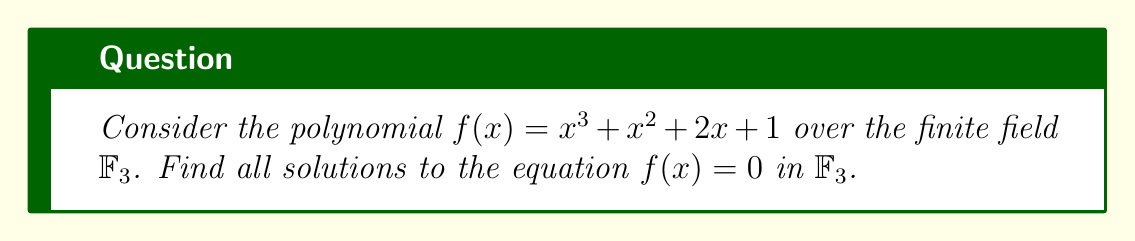Solve this math problem. To solve this polynomial equation over $\mathbb{F}_3$, we'll use factorization techniques:

1) First, recall that in $\mathbb{F}_3$, all elements are congruent to 0, 1, or 2 mod 3.

2) We can try to factor $f(x)$ by testing all possible linear factors $(x - a)$ where $a \in \mathbb{F}_3$:

   For $a = 0$: $f(0) = 0^3 + 0^2 + 2(0) + 1 \equiv 1 \pmod{3}$
   For $a = 1$: $f(1) = 1^3 + 1^2 + 2(1) + 1 \equiv 2 \pmod{3}$
   For $a = 2$: $f(2) = 2^3 + 2^2 + 2(2) + 1 \equiv 0 \pmod{3}$

3) We found that $(x - 2)$ is a factor of $f(x)$ in $\mathbb{F}_3$.

4) Divide $f(x)$ by $(x - 2)$ in $\mathbb{F}_3$:

   $x^3 + x^2 + 2x + 1 = (x - 2)(x^2 + 2x + 2)$

5) Now we need to factor $x^2 + 2x + 2$ in $\mathbb{F}_3$. We can use the quadratic formula or try all possible factors:

   For $a = 0$: $0^2 + 2(0) + 2 \equiv 2 \pmod{3}$
   For $a = 1$: $1^2 + 2(1) + 2 \equiv 2 \pmod{3}$
   For $a = 2$: $2^2 + 2(2) + 2 \equiv 0 \pmod{3}$

6) We found that $(x - 2)$ is also a factor of $x^2 + 2x + 2$ in $\mathbb{F}_3$.

7) Dividing $x^2 + 2x + 2$ by $(x - 2)$ in $\mathbb{F}_3$, we get:

   $x^2 + 2x + 2 = (x - 2)(x + 1)$

8) Therefore, the complete factorization of $f(x)$ in $\mathbb{F}_3$ is:

   $f(x) = (x - 2)(x - 2)(x + 1)$

9) The solutions to $f(x) = 0$ in $\mathbb{F}_3$ are the roots of these factors: $x = 2$ (with multiplicity 2) and $x = 2$ (since $-1 \equiv 2 \pmod{3}$).
Answer: $x = 2$ (with multiplicity 3) 